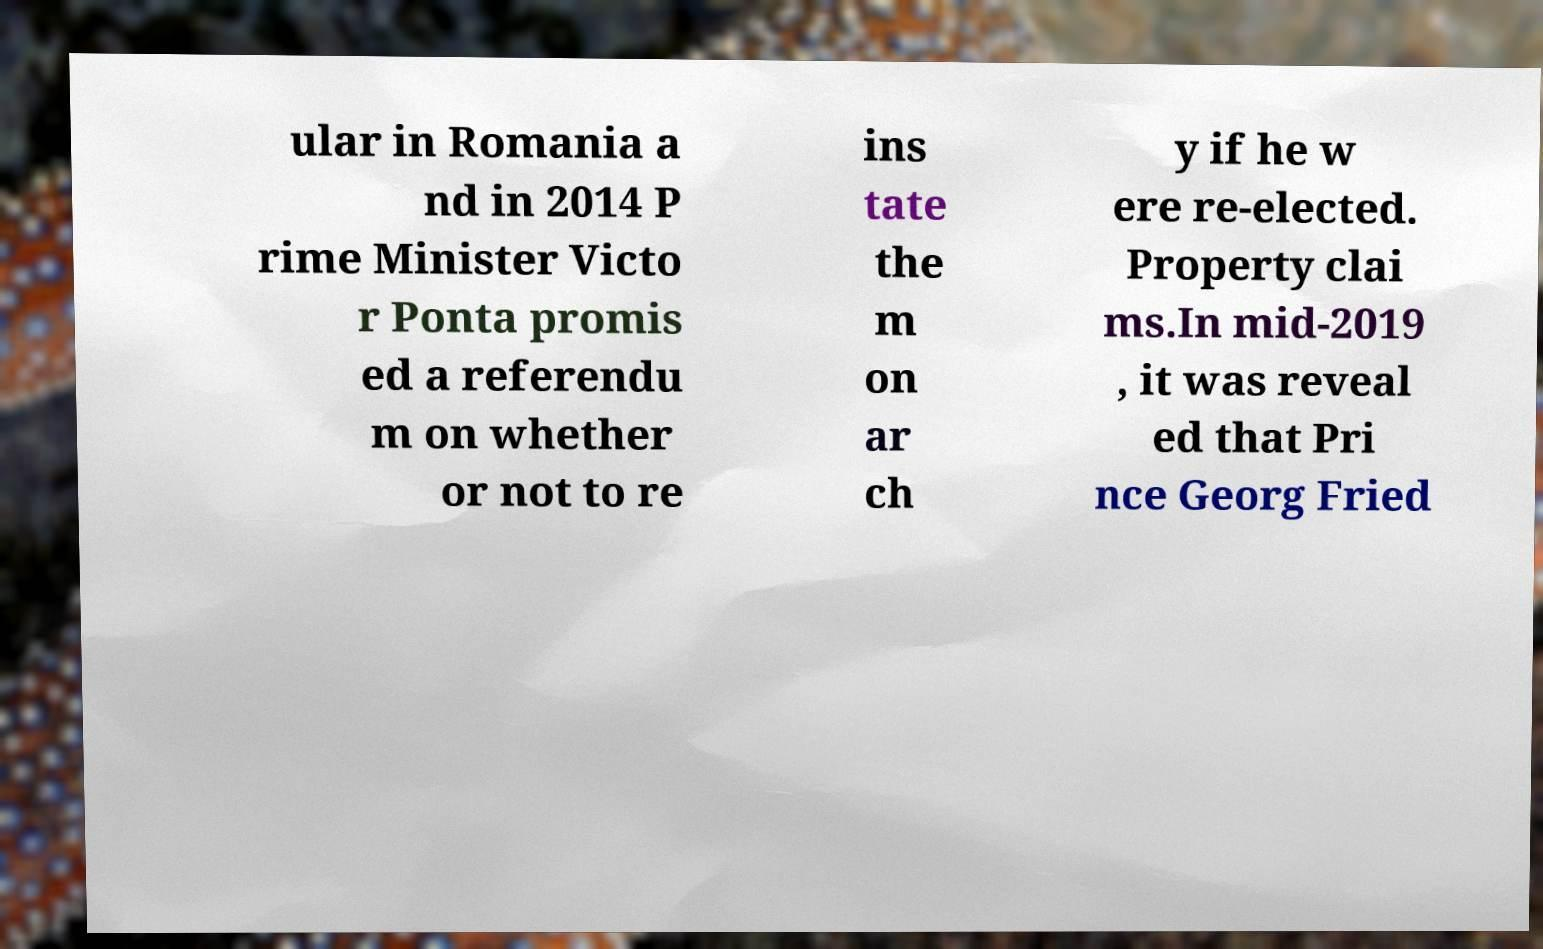What messages or text are displayed in this image? I need them in a readable, typed format. ular in Romania a nd in 2014 P rime Minister Victo r Ponta promis ed a referendu m on whether or not to re ins tate the m on ar ch y if he w ere re-elected. Property clai ms.In mid-2019 , it was reveal ed that Pri nce Georg Fried 